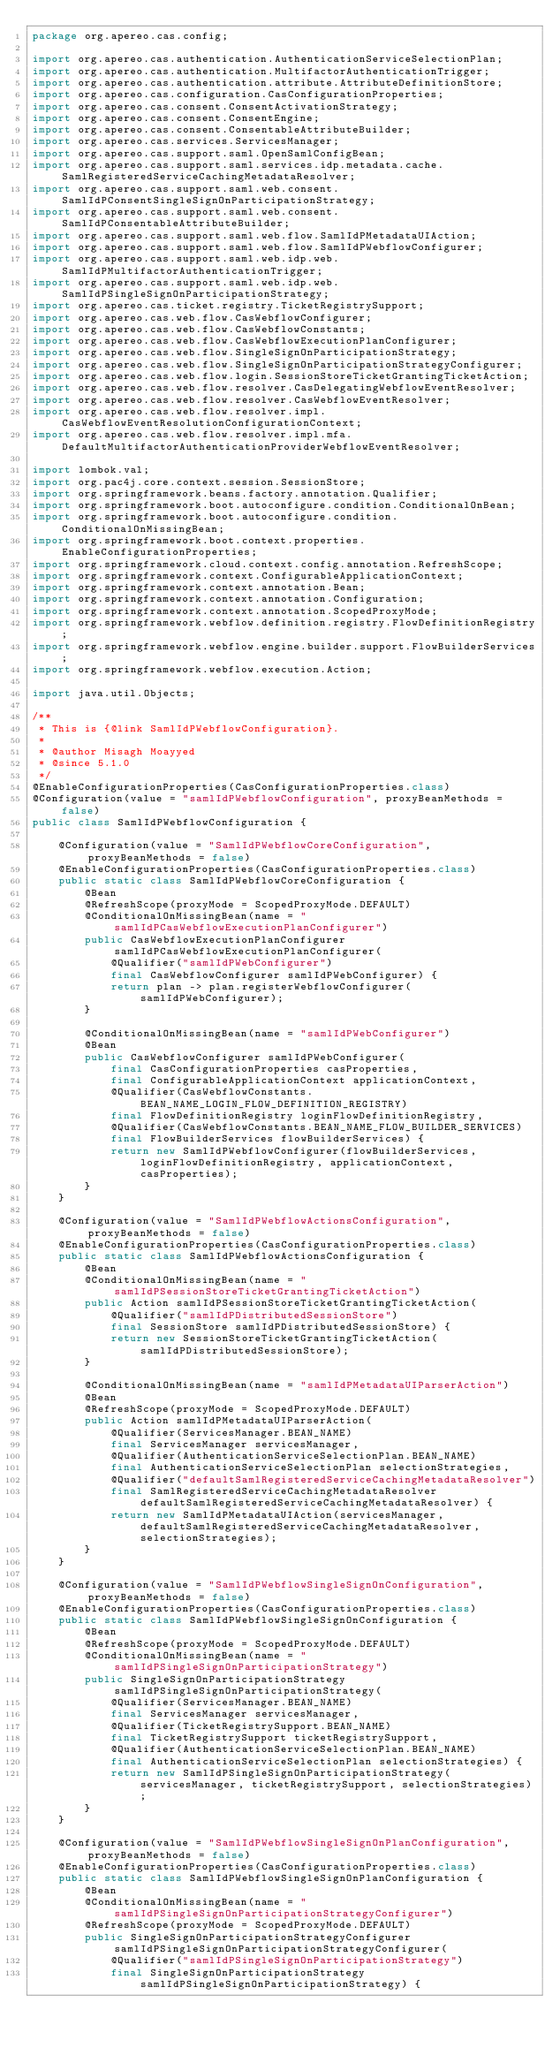Convert code to text. <code><loc_0><loc_0><loc_500><loc_500><_Java_>package org.apereo.cas.config;

import org.apereo.cas.authentication.AuthenticationServiceSelectionPlan;
import org.apereo.cas.authentication.MultifactorAuthenticationTrigger;
import org.apereo.cas.authentication.attribute.AttributeDefinitionStore;
import org.apereo.cas.configuration.CasConfigurationProperties;
import org.apereo.cas.consent.ConsentActivationStrategy;
import org.apereo.cas.consent.ConsentEngine;
import org.apereo.cas.consent.ConsentableAttributeBuilder;
import org.apereo.cas.services.ServicesManager;
import org.apereo.cas.support.saml.OpenSamlConfigBean;
import org.apereo.cas.support.saml.services.idp.metadata.cache.SamlRegisteredServiceCachingMetadataResolver;
import org.apereo.cas.support.saml.web.consent.SamlIdPConsentSingleSignOnParticipationStrategy;
import org.apereo.cas.support.saml.web.consent.SamlIdPConsentableAttributeBuilder;
import org.apereo.cas.support.saml.web.flow.SamlIdPMetadataUIAction;
import org.apereo.cas.support.saml.web.flow.SamlIdPWebflowConfigurer;
import org.apereo.cas.support.saml.web.idp.web.SamlIdPMultifactorAuthenticationTrigger;
import org.apereo.cas.support.saml.web.idp.web.SamlIdPSingleSignOnParticipationStrategy;
import org.apereo.cas.ticket.registry.TicketRegistrySupport;
import org.apereo.cas.web.flow.CasWebflowConfigurer;
import org.apereo.cas.web.flow.CasWebflowConstants;
import org.apereo.cas.web.flow.CasWebflowExecutionPlanConfigurer;
import org.apereo.cas.web.flow.SingleSignOnParticipationStrategy;
import org.apereo.cas.web.flow.SingleSignOnParticipationStrategyConfigurer;
import org.apereo.cas.web.flow.login.SessionStoreTicketGrantingTicketAction;
import org.apereo.cas.web.flow.resolver.CasDelegatingWebflowEventResolver;
import org.apereo.cas.web.flow.resolver.CasWebflowEventResolver;
import org.apereo.cas.web.flow.resolver.impl.CasWebflowEventResolutionConfigurationContext;
import org.apereo.cas.web.flow.resolver.impl.mfa.DefaultMultifactorAuthenticationProviderWebflowEventResolver;

import lombok.val;
import org.pac4j.core.context.session.SessionStore;
import org.springframework.beans.factory.annotation.Qualifier;
import org.springframework.boot.autoconfigure.condition.ConditionalOnBean;
import org.springframework.boot.autoconfigure.condition.ConditionalOnMissingBean;
import org.springframework.boot.context.properties.EnableConfigurationProperties;
import org.springframework.cloud.context.config.annotation.RefreshScope;
import org.springframework.context.ConfigurableApplicationContext;
import org.springframework.context.annotation.Bean;
import org.springframework.context.annotation.Configuration;
import org.springframework.context.annotation.ScopedProxyMode;
import org.springframework.webflow.definition.registry.FlowDefinitionRegistry;
import org.springframework.webflow.engine.builder.support.FlowBuilderServices;
import org.springframework.webflow.execution.Action;

import java.util.Objects;

/**
 * This is {@link SamlIdPWebflowConfiguration}.
 *
 * @author Misagh Moayyed
 * @since 5.1.0
 */
@EnableConfigurationProperties(CasConfigurationProperties.class)
@Configuration(value = "samlIdPWebflowConfiguration", proxyBeanMethods = false)
public class SamlIdPWebflowConfiguration {

    @Configuration(value = "SamlIdPWebflowCoreConfiguration", proxyBeanMethods = false)
    @EnableConfigurationProperties(CasConfigurationProperties.class)
    public static class SamlIdPWebflowCoreConfiguration {
        @Bean
        @RefreshScope(proxyMode = ScopedProxyMode.DEFAULT)
        @ConditionalOnMissingBean(name = "samlIdPCasWebflowExecutionPlanConfigurer")
        public CasWebflowExecutionPlanConfigurer samlIdPCasWebflowExecutionPlanConfigurer(
            @Qualifier("samlIdPWebConfigurer")
            final CasWebflowConfigurer samlIdPWebConfigurer) {
            return plan -> plan.registerWebflowConfigurer(samlIdPWebConfigurer);
        }

        @ConditionalOnMissingBean(name = "samlIdPWebConfigurer")
        @Bean
        public CasWebflowConfigurer samlIdPWebConfigurer(
            final CasConfigurationProperties casProperties,
            final ConfigurableApplicationContext applicationContext,
            @Qualifier(CasWebflowConstants.BEAN_NAME_LOGIN_FLOW_DEFINITION_REGISTRY)
            final FlowDefinitionRegistry loginFlowDefinitionRegistry,
            @Qualifier(CasWebflowConstants.BEAN_NAME_FLOW_BUILDER_SERVICES)
            final FlowBuilderServices flowBuilderServices) {
            return new SamlIdPWebflowConfigurer(flowBuilderServices, loginFlowDefinitionRegistry, applicationContext, casProperties);
        }
    }

    @Configuration(value = "SamlIdPWebflowActionsConfiguration", proxyBeanMethods = false)
    @EnableConfigurationProperties(CasConfigurationProperties.class)
    public static class SamlIdPWebflowActionsConfiguration {
        @Bean
        @ConditionalOnMissingBean(name = "samlIdPSessionStoreTicketGrantingTicketAction")
        public Action samlIdPSessionStoreTicketGrantingTicketAction(
            @Qualifier("samlIdPDistributedSessionStore")
            final SessionStore samlIdPDistributedSessionStore) {
            return new SessionStoreTicketGrantingTicketAction(samlIdPDistributedSessionStore);
        }

        @ConditionalOnMissingBean(name = "samlIdPMetadataUIParserAction")
        @Bean
        @RefreshScope(proxyMode = ScopedProxyMode.DEFAULT)
        public Action samlIdPMetadataUIParserAction(
            @Qualifier(ServicesManager.BEAN_NAME)
            final ServicesManager servicesManager,
            @Qualifier(AuthenticationServiceSelectionPlan.BEAN_NAME)
            final AuthenticationServiceSelectionPlan selectionStrategies,
            @Qualifier("defaultSamlRegisteredServiceCachingMetadataResolver")
            final SamlRegisteredServiceCachingMetadataResolver defaultSamlRegisteredServiceCachingMetadataResolver) {
            return new SamlIdPMetadataUIAction(servicesManager, defaultSamlRegisteredServiceCachingMetadataResolver, selectionStrategies);
        }
    }

    @Configuration(value = "SamlIdPWebflowSingleSignOnConfiguration", proxyBeanMethods = false)
    @EnableConfigurationProperties(CasConfigurationProperties.class)
    public static class SamlIdPWebflowSingleSignOnConfiguration {
        @Bean
        @RefreshScope(proxyMode = ScopedProxyMode.DEFAULT)
        @ConditionalOnMissingBean(name = "samlIdPSingleSignOnParticipationStrategy")
        public SingleSignOnParticipationStrategy samlIdPSingleSignOnParticipationStrategy(
            @Qualifier(ServicesManager.BEAN_NAME)
            final ServicesManager servicesManager,
            @Qualifier(TicketRegistrySupport.BEAN_NAME)
            final TicketRegistrySupport ticketRegistrySupport,
            @Qualifier(AuthenticationServiceSelectionPlan.BEAN_NAME)
            final AuthenticationServiceSelectionPlan selectionStrategies) {
            return new SamlIdPSingleSignOnParticipationStrategy(servicesManager, ticketRegistrySupport, selectionStrategies);
        }
    }

    @Configuration(value = "SamlIdPWebflowSingleSignOnPlanConfiguration", proxyBeanMethods = false)
    @EnableConfigurationProperties(CasConfigurationProperties.class)
    public static class SamlIdPWebflowSingleSignOnPlanConfiguration {
        @Bean
        @ConditionalOnMissingBean(name = "samlIdPSingleSignOnParticipationStrategyConfigurer")
        @RefreshScope(proxyMode = ScopedProxyMode.DEFAULT)
        public SingleSignOnParticipationStrategyConfigurer samlIdPSingleSignOnParticipationStrategyConfigurer(
            @Qualifier("samlIdPSingleSignOnParticipationStrategy")
            final SingleSignOnParticipationStrategy samlIdPSingleSignOnParticipationStrategy) {</code> 